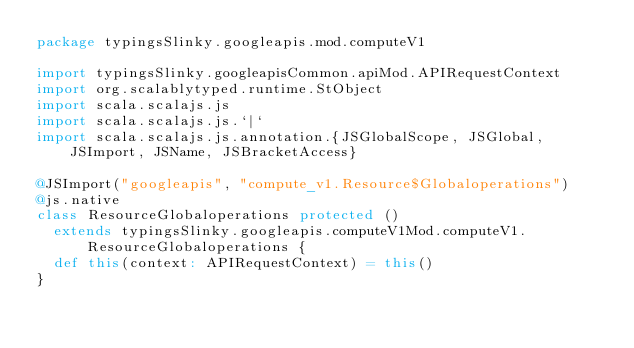<code> <loc_0><loc_0><loc_500><loc_500><_Scala_>package typingsSlinky.googleapis.mod.computeV1

import typingsSlinky.googleapisCommon.apiMod.APIRequestContext
import org.scalablytyped.runtime.StObject
import scala.scalajs.js
import scala.scalajs.js.`|`
import scala.scalajs.js.annotation.{JSGlobalScope, JSGlobal, JSImport, JSName, JSBracketAccess}

@JSImport("googleapis", "compute_v1.Resource$Globaloperations")
@js.native
class ResourceGlobaloperations protected ()
  extends typingsSlinky.googleapis.computeV1Mod.computeV1.ResourceGlobaloperations {
  def this(context: APIRequestContext) = this()
}
</code> 